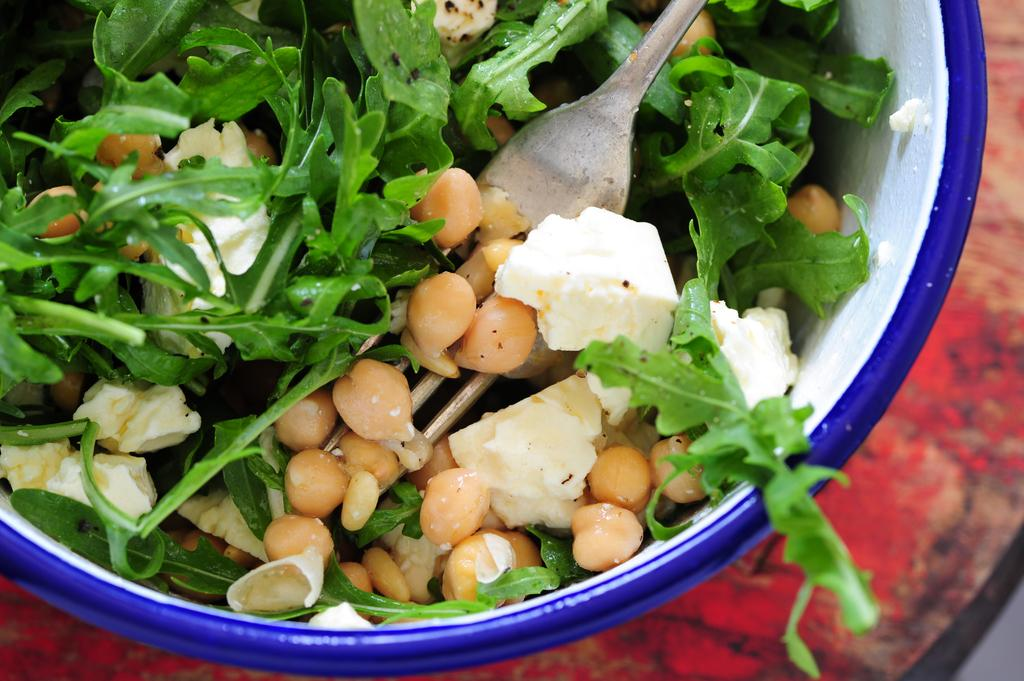What is on the table in the image? There is a bowl on the table in the image. What is inside the bowl? The bowl contains a spoon and leafy vegetables. Is there any food in the bowl? Yes, there is food in the bowl, which consists of leafy vegetables. What type of stem can be seen in the bowl? There is no stem present in the bowl; it contains leafy vegetables. 